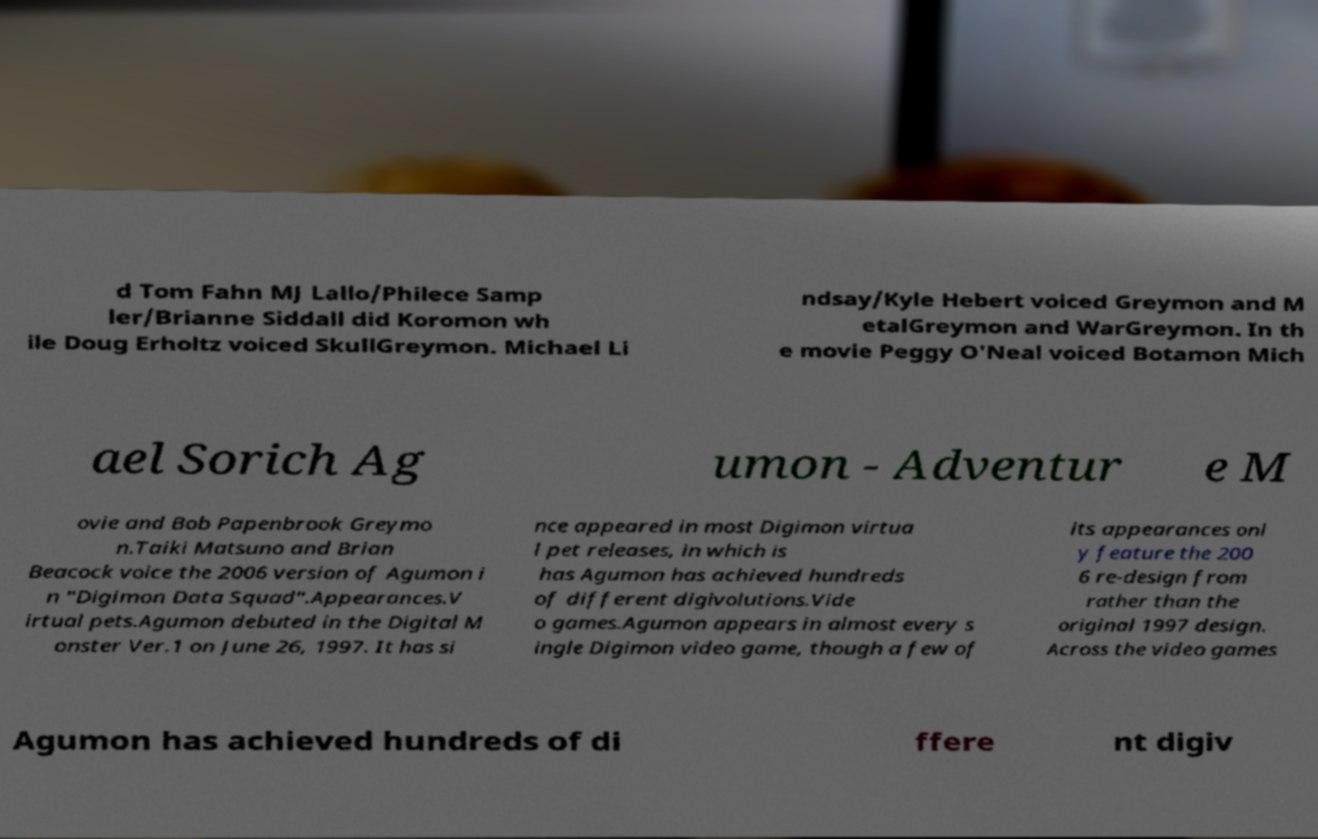What messages or text are displayed in this image? I need them in a readable, typed format. d Tom Fahn MJ Lallo/Philece Samp ler/Brianne Siddall did Koromon wh ile Doug Erholtz voiced SkullGreymon. Michael Li ndsay/Kyle Hebert voiced Greymon and M etalGreymon and WarGreymon. In th e movie Peggy O'Neal voiced Botamon Mich ael Sorich Ag umon - Adventur e M ovie and Bob Papenbrook Greymo n.Taiki Matsuno and Brian Beacock voice the 2006 version of Agumon i n "Digimon Data Squad".Appearances.V irtual pets.Agumon debuted in the Digital M onster Ver.1 on June 26, 1997. It has si nce appeared in most Digimon virtua l pet releases, in which is has Agumon has achieved hundreds of different digivolutions.Vide o games.Agumon appears in almost every s ingle Digimon video game, though a few of its appearances onl y feature the 200 6 re-design from rather than the original 1997 design. Across the video games Agumon has achieved hundreds of di ffere nt digiv 